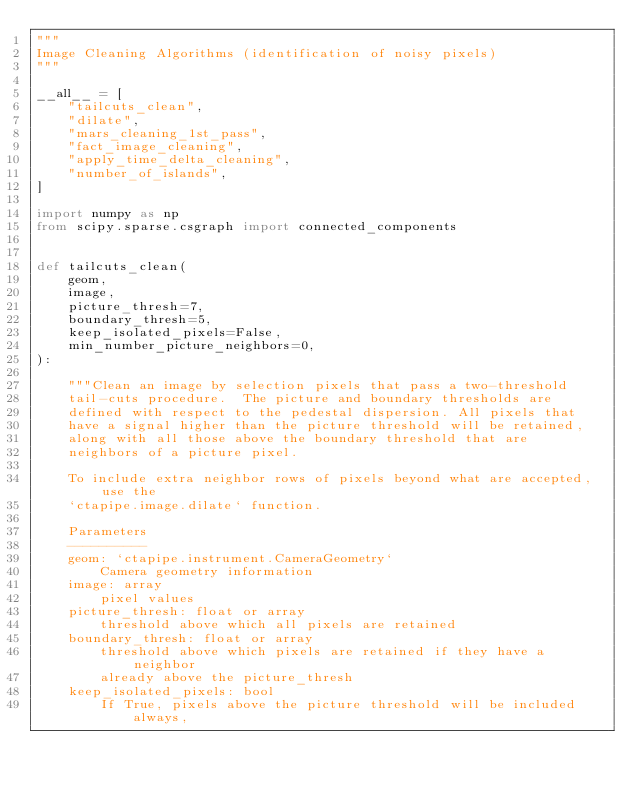<code> <loc_0><loc_0><loc_500><loc_500><_Python_>"""
Image Cleaning Algorithms (identification of noisy pixels)
"""

__all__ = [
    "tailcuts_clean",
    "dilate",
    "mars_cleaning_1st_pass",
    "fact_image_cleaning",
    "apply_time_delta_cleaning",
    "number_of_islands",
]

import numpy as np
from scipy.sparse.csgraph import connected_components


def tailcuts_clean(
    geom,
    image,
    picture_thresh=7,
    boundary_thresh=5,
    keep_isolated_pixels=False,
    min_number_picture_neighbors=0,
):

    """Clean an image by selection pixels that pass a two-threshold
    tail-cuts procedure.  The picture and boundary thresholds are
    defined with respect to the pedestal dispersion. All pixels that
    have a signal higher than the picture threshold will be retained,
    along with all those above the boundary threshold that are
    neighbors of a picture pixel.

    To include extra neighbor rows of pixels beyond what are accepted, use the
    `ctapipe.image.dilate` function.

    Parameters
    ----------
    geom: `ctapipe.instrument.CameraGeometry`
        Camera geometry information
    image: array
        pixel values
    picture_thresh: float or array
        threshold above which all pixels are retained
    boundary_thresh: float or array
        threshold above which pixels are retained if they have a neighbor
        already above the picture_thresh
    keep_isolated_pixels: bool
        If True, pixels above the picture threshold will be included always,</code> 